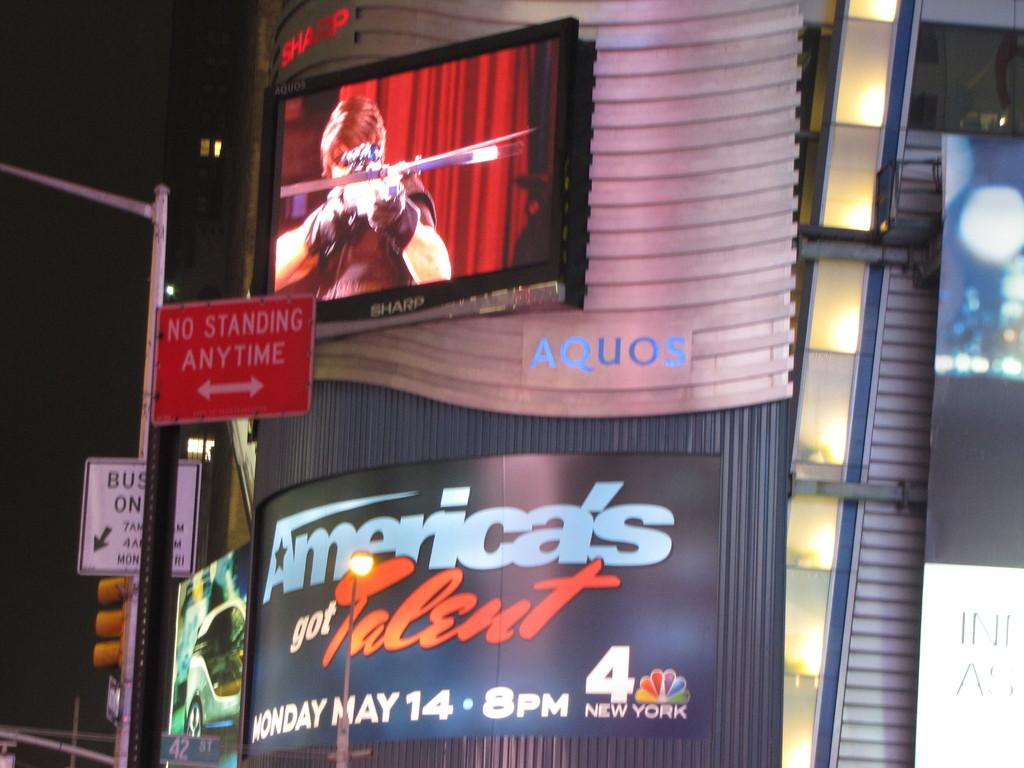<image>
Share a concise interpretation of the image provided. A video billboard for America's Got Talent is playing. 